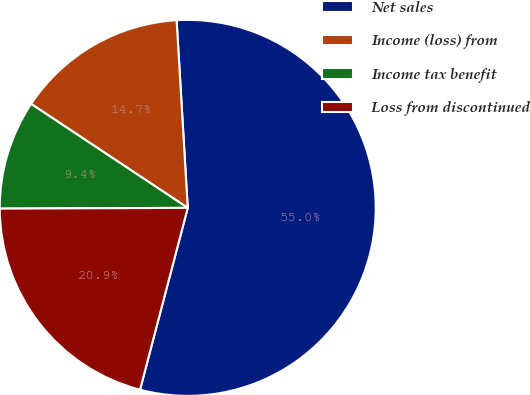Convert chart. <chart><loc_0><loc_0><loc_500><loc_500><pie_chart><fcel>Net sales<fcel>Income (loss) from<fcel>Income tax benefit<fcel>Loss from discontinued<nl><fcel>55.02%<fcel>14.73%<fcel>9.39%<fcel>20.85%<nl></chart> 